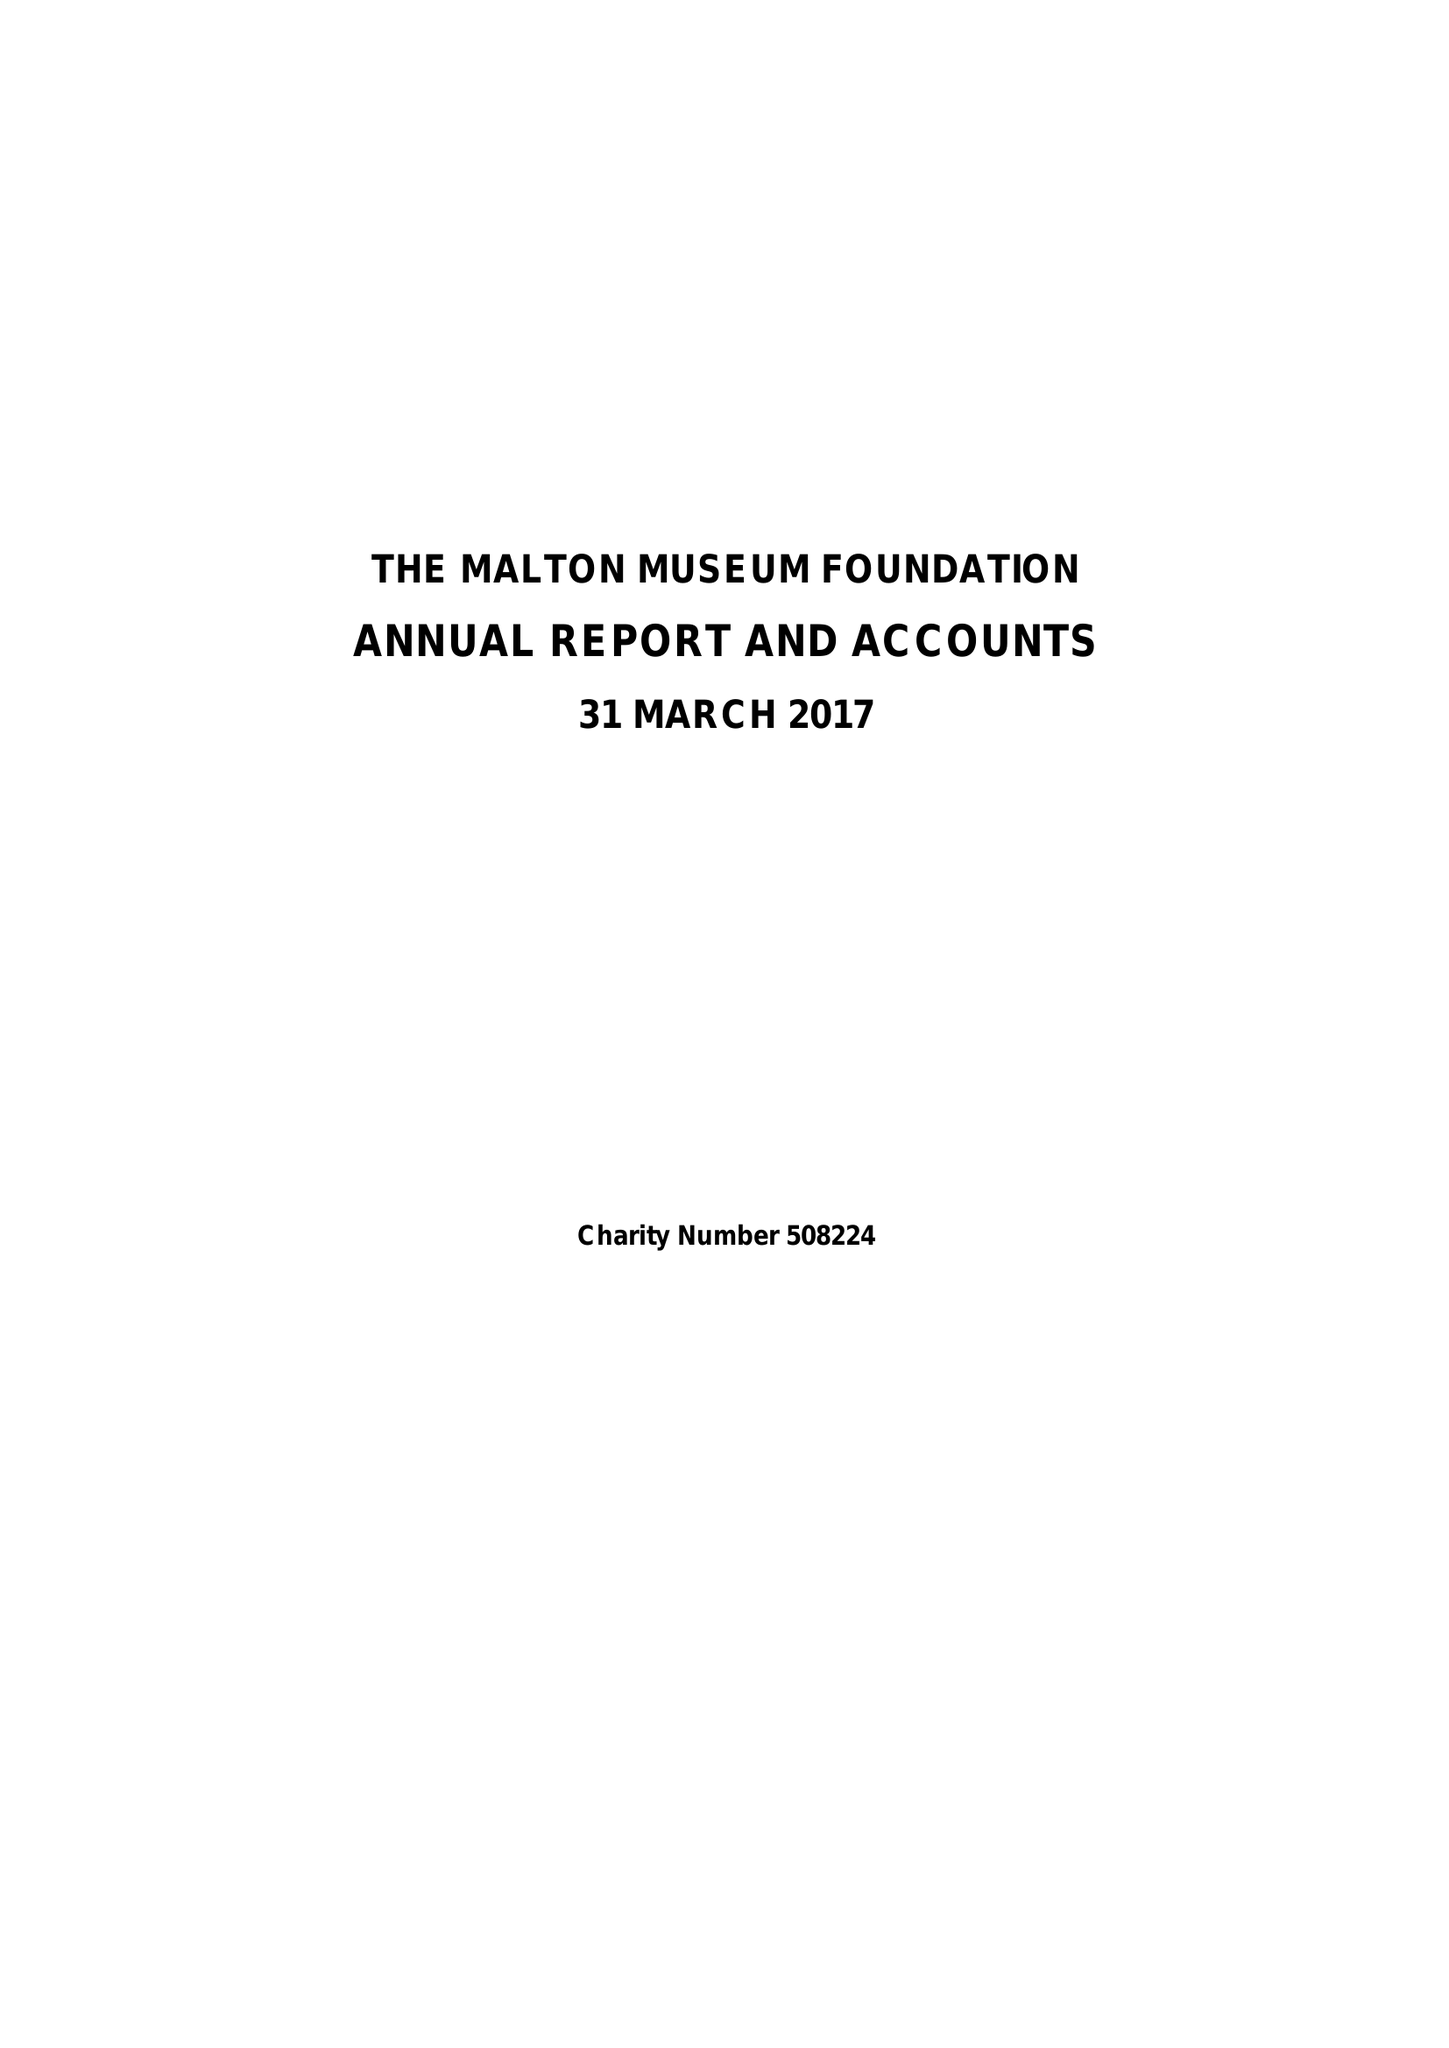What is the value for the report_date?
Answer the question using a single word or phrase. 2017-03-31 